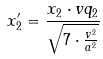<formula> <loc_0><loc_0><loc_500><loc_500>x _ { 2 } ^ { \prime } = \frac { x _ { 2 } \cdot v q _ { 2 } } { \sqrt { 7 \cdot \frac { v ^ { 2 } } { a ^ { 2 } } } }</formula> 